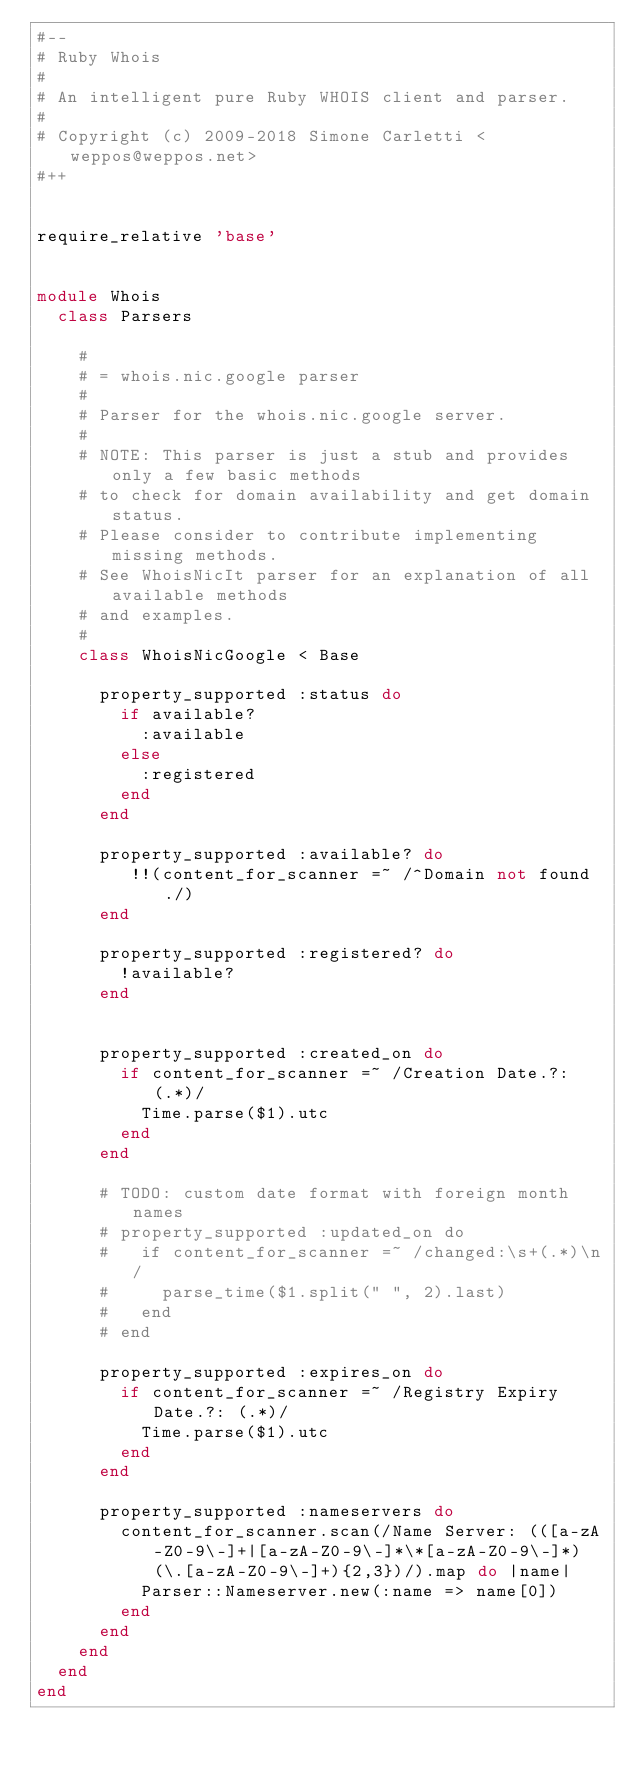<code> <loc_0><loc_0><loc_500><loc_500><_Ruby_>#--
# Ruby Whois
#
# An intelligent pure Ruby WHOIS client and parser.
#
# Copyright (c) 2009-2018 Simone Carletti <weppos@weppos.net>
#++


require_relative 'base'


module Whois
  class Parsers

    #
    # = whois.nic.google parser
    #
    # Parser for the whois.nic.google server.
    #
    # NOTE: This parser is just a stub and provides only a few basic methods
    # to check for domain availability and get domain status.
    # Please consider to contribute implementing missing methods.
    # See WhoisNicIt parser for an explanation of all available methods
    # and examples.
    #
    class WhoisNicGoogle < Base

      property_supported :status do
        if available?
          :available
        else
          :registered
        end
      end

      property_supported :available? do
         !!(content_for_scanner =~ /^Domain not found./)
      end

      property_supported :registered? do
        !available?
      end


      property_supported :created_on do
        if content_for_scanner =~ /Creation Date.?: (.*)/
          Time.parse($1).utc
        end
      end

      # TODO: custom date format with foreign month names
      # property_supported :updated_on do
      #   if content_for_scanner =~ /changed:\s+(.*)\n/
      #     parse_time($1.split(" ", 2).last)
      #   end
      # end

      property_supported :expires_on do
        if content_for_scanner =~ /Registry Expiry Date.?: (.*)/
          Time.parse($1).utc
        end
      end

      property_supported :nameservers do
        content_for_scanner.scan(/Name Server: (([a-zA-Z0-9\-]+|[a-zA-Z0-9\-]*\*[a-zA-Z0-9\-]*)(\.[a-zA-Z0-9\-]+){2,3})/).map do |name|
          Parser::Nameserver.new(:name => name[0])
        end
      end
    end
  end
end
</code> 